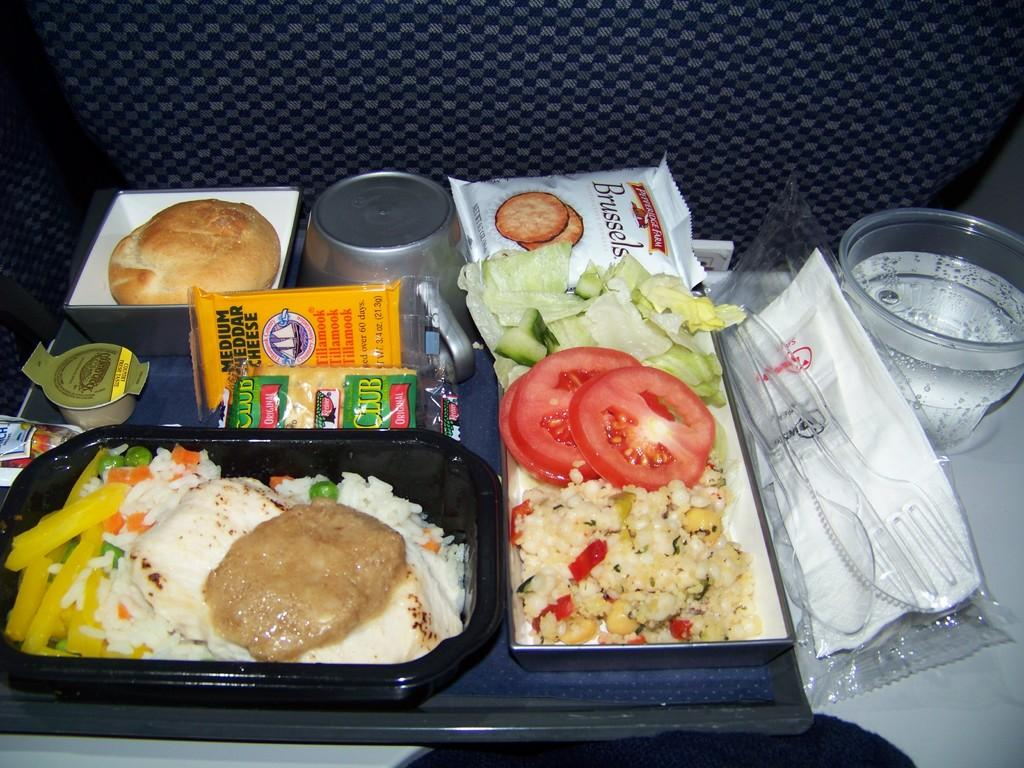What is on the plate in the image? There is food placed on a plate in the image. Where is the plate located? The plate is placed on a chair in the image. What else can be seen on the chair? There is a drink and other objects on the chair in the image. How many frogs are sitting on the birthday cake in the image? There is no birthday cake or frogs present in the image. 